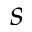Convert formula to latex. <formula><loc_0><loc_0><loc_500><loc_500>s</formula> 